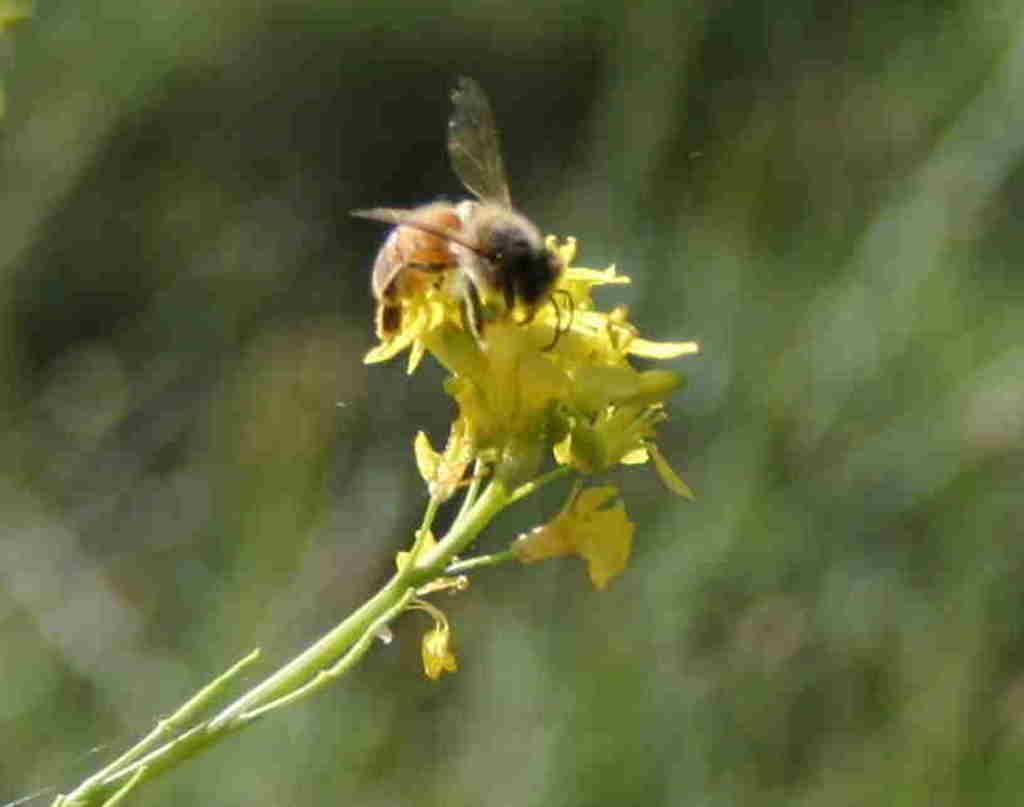What type of insect is in the image? There is a honey bee in the image. Where is the honey bee located in the image? The honey bee is on the flowers. What type of tin can be seen near the honey bee in the image? There is no tin present in the image; it features a honey bee on flowers. Can you describe the faucet that the honey bee is using to collect water in the image? There is no faucet present in the image, as honey bees typically collect nectar and pollen from flowers, not water from a faucet. 